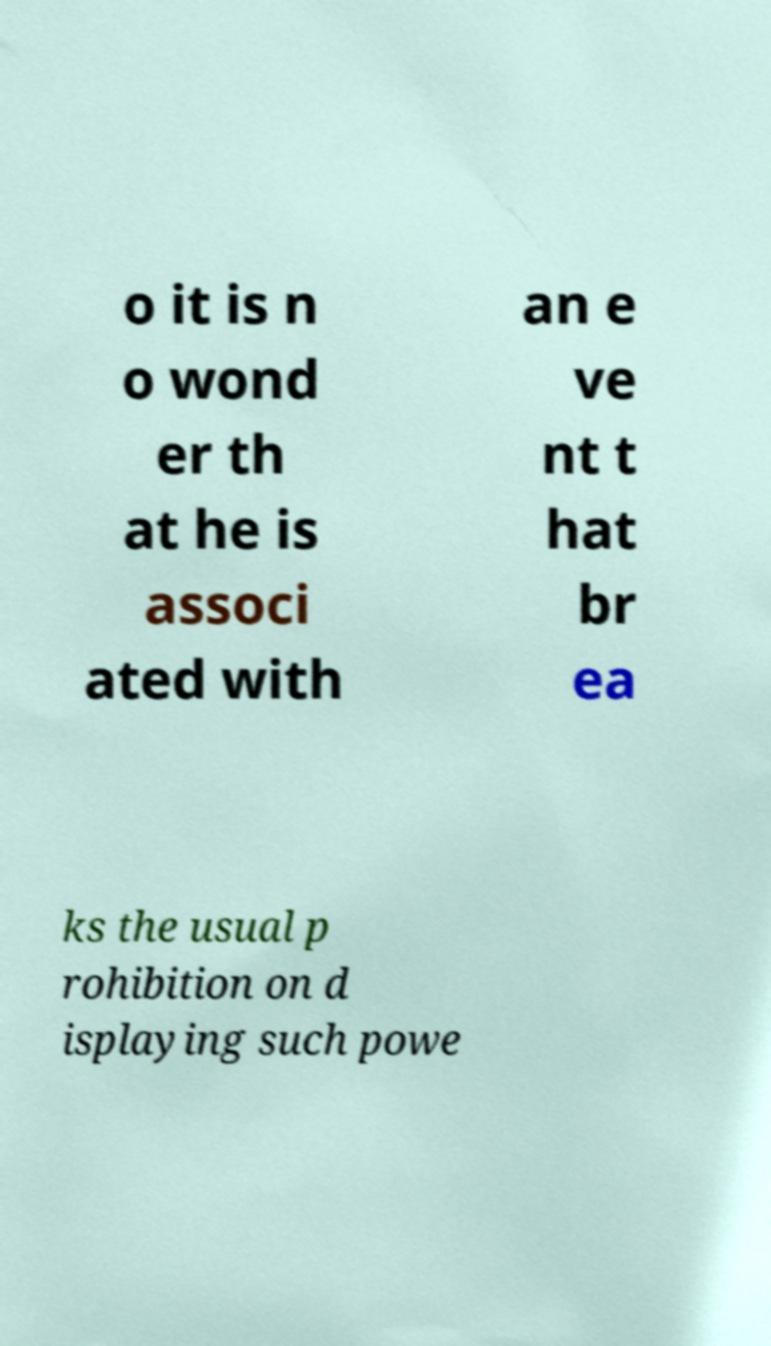What messages or text are displayed in this image? I need them in a readable, typed format. o it is n o wond er th at he is associ ated with an e ve nt t hat br ea ks the usual p rohibition on d isplaying such powe 